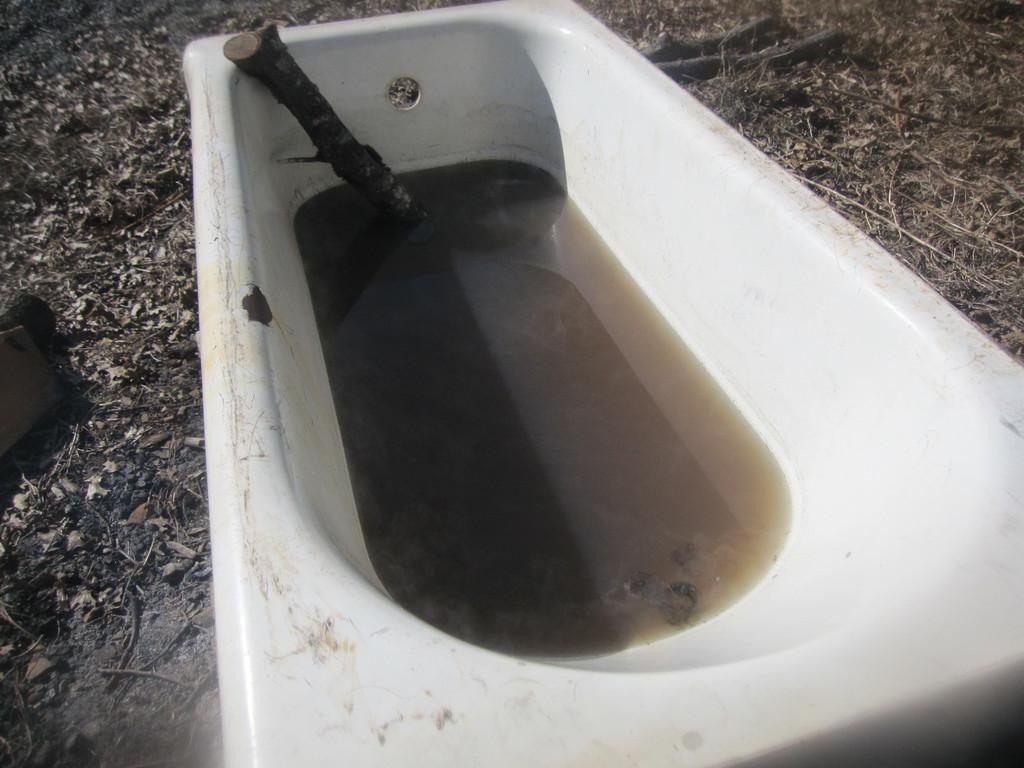What is the main object in the image? There is a bathtub in the image. How is the bathtub positioned in the image? The bathtub is placed on the ground. What is inside the bathtub? There is water in the bathtub. What type of error can be seen in the image? There is no error present in the image; it features a bathtub with water in it. What tool is being used to fix the bathtub in the image? There is no tool or repair work being done in the image; it simply shows a bathtub with water in it. 